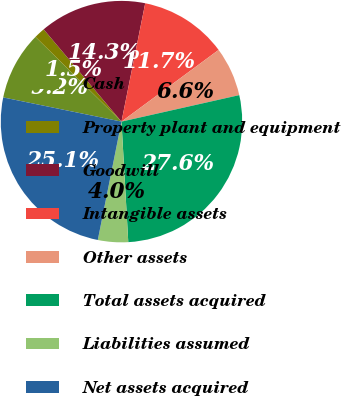Convert chart to OTSL. <chart><loc_0><loc_0><loc_500><loc_500><pie_chart><fcel>Cash<fcel>Property plant and equipment<fcel>Goodwill<fcel>Intangible assets<fcel>Other assets<fcel>Total assets acquired<fcel>Liabilities assumed<fcel>Net assets acquired<nl><fcel>9.17%<fcel>1.47%<fcel>14.3%<fcel>11.73%<fcel>6.6%<fcel>27.63%<fcel>4.04%<fcel>25.07%<nl></chart> 